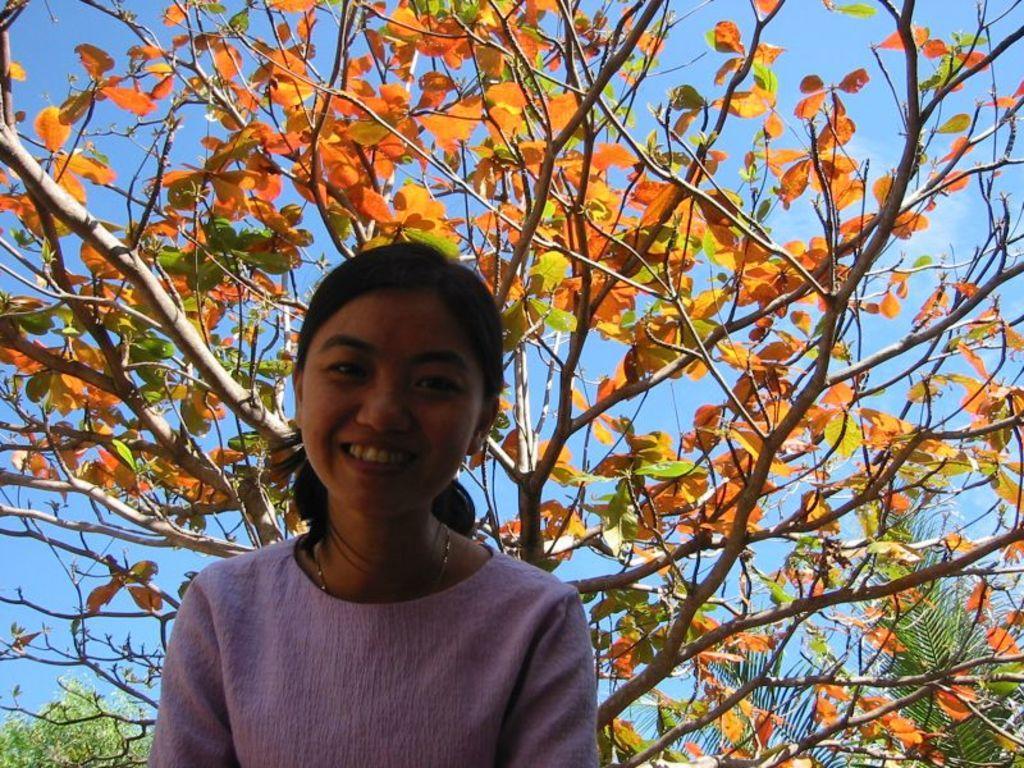Please provide a concise description of this image. In this picture there is a woman with pink dress is smiling. At the back there are different types of trees. At the top there is sky. 